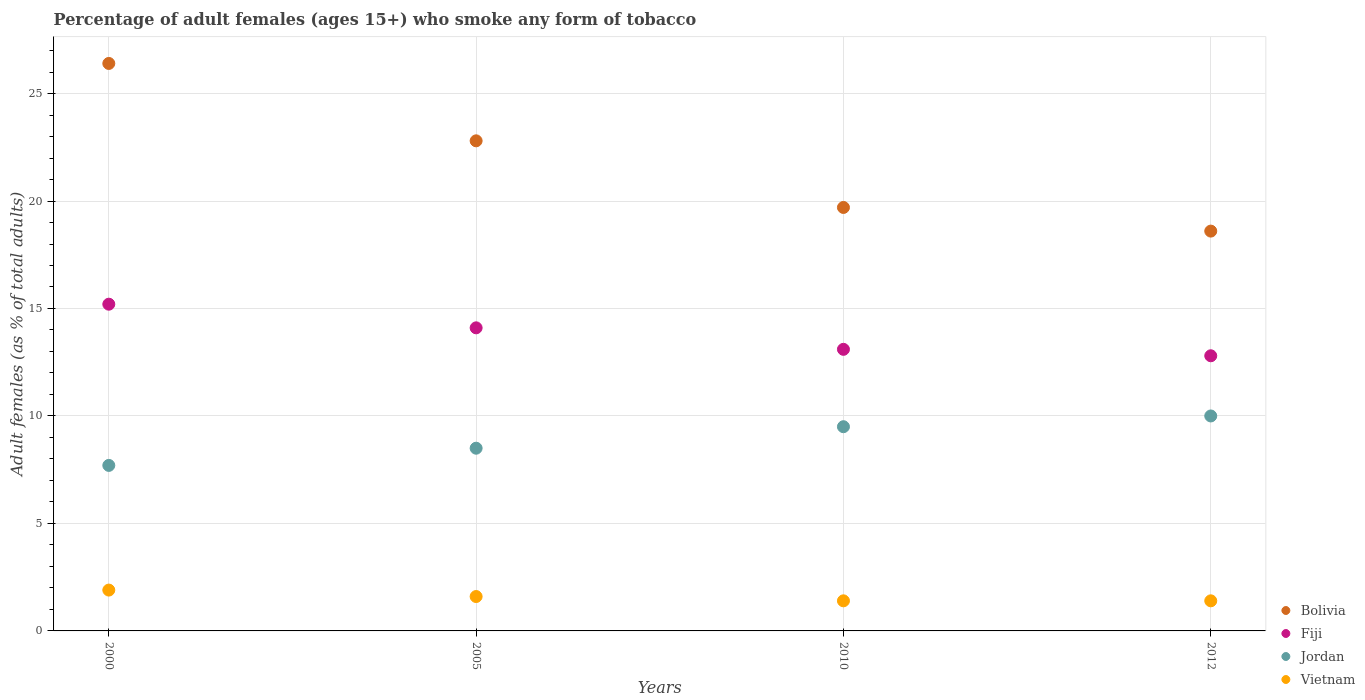How many different coloured dotlines are there?
Keep it short and to the point. 4. What is the percentage of adult females who smoke in Bolivia in 2010?
Your answer should be compact. 19.7. Across all years, what is the maximum percentage of adult females who smoke in Bolivia?
Provide a short and direct response. 26.4. Across all years, what is the minimum percentage of adult females who smoke in Bolivia?
Make the answer very short. 18.6. In which year was the percentage of adult females who smoke in Jordan minimum?
Your answer should be very brief. 2000. What is the total percentage of adult females who smoke in Jordan in the graph?
Your response must be concise. 35.7. What is the difference between the percentage of adult females who smoke in Fiji in 2000 and that in 2012?
Give a very brief answer. 2.4. What is the difference between the percentage of adult females who smoke in Jordan in 2005 and the percentage of adult females who smoke in Fiji in 2010?
Your answer should be very brief. -4.6. What is the average percentage of adult females who smoke in Vietnam per year?
Your answer should be compact. 1.58. In how many years, is the percentage of adult females who smoke in Vietnam greater than 10 %?
Provide a short and direct response. 0. What is the ratio of the percentage of adult females who smoke in Vietnam in 2000 to that in 2005?
Make the answer very short. 1.19. Is the difference between the percentage of adult females who smoke in Bolivia in 2000 and 2010 greater than the difference between the percentage of adult females who smoke in Jordan in 2000 and 2010?
Make the answer very short. Yes. What is the difference between the highest and the second highest percentage of adult females who smoke in Fiji?
Offer a very short reply. 1.1. What is the difference between the highest and the lowest percentage of adult females who smoke in Fiji?
Provide a succinct answer. 2.4. In how many years, is the percentage of adult females who smoke in Fiji greater than the average percentage of adult females who smoke in Fiji taken over all years?
Keep it short and to the point. 2. How many dotlines are there?
Make the answer very short. 4. Are the values on the major ticks of Y-axis written in scientific E-notation?
Offer a very short reply. No. Does the graph contain grids?
Keep it short and to the point. Yes. Where does the legend appear in the graph?
Provide a succinct answer. Bottom right. How are the legend labels stacked?
Provide a succinct answer. Vertical. What is the title of the graph?
Your answer should be very brief. Percentage of adult females (ages 15+) who smoke any form of tobacco. What is the label or title of the Y-axis?
Ensure brevity in your answer.  Adult females (as % of total adults). What is the Adult females (as % of total adults) in Bolivia in 2000?
Provide a succinct answer. 26.4. What is the Adult females (as % of total adults) of Fiji in 2000?
Make the answer very short. 15.2. What is the Adult females (as % of total adults) of Jordan in 2000?
Your response must be concise. 7.7. What is the Adult females (as % of total adults) in Vietnam in 2000?
Offer a very short reply. 1.9. What is the Adult females (as % of total adults) of Bolivia in 2005?
Give a very brief answer. 22.8. What is the Adult females (as % of total adults) of Jordan in 2005?
Make the answer very short. 8.5. What is the Adult females (as % of total adults) of Fiji in 2010?
Give a very brief answer. 13.1. What is the Adult females (as % of total adults) in Bolivia in 2012?
Offer a terse response. 18.6. Across all years, what is the maximum Adult females (as % of total adults) of Bolivia?
Provide a succinct answer. 26.4. Across all years, what is the maximum Adult females (as % of total adults) in Fiji?
Your answer should be very brief. 15.2. Across all years, what is the minimum Adult females (as % of total adults) of Bolivia?
Your answer should be compact. 18.6. Across all years, what is the minimum Adult females (as % of total adults) in Fiji?
Offer a terse response. 12.8. Across all years, what is the minimum Adult females (as % of total adults) of Jordan?
Ensure brevity in your answer.  7.7. Across all years, what is the minimum Adult females (as % of total adults) in Vietnam?
Provide a short and direct response. 1.4. What is the total Adult females (as % of total adults) in Bolivia in the graph?
Offer a very short reply. 87.5. What is the total Adult females (as % of total adults) of Fiji in the graph?
Your response must be concise. 55.2. What is the total Adult females (as % of total adults) in Jordan in the graph?
Offer a terse response. 35.7. What is the total Adult females (as % of total adults) of Vietnam in the graph?
Your answer should be very brief. 6.3. What is the difference between the Adult females (as % of total adults) in Fiji in 2000 and that in 2005?
Ensure brevity in your answer.  1.1. What is the difference between the Adult females (as % of total adults) of Jordan in 2000 and that in 2005?
Keep it short and to the point. -0.8. What is the difference between the Adult females (as % of total adults) in Bolivia in 2000 and that in 2010?
Ensure brevity in your answer.  6.7. What is the difference between the Adult females (as % of total adults) in Fiji in 2000 and that in 2012?
Offer a terse response. 2.4. What is the difference between the Adult females (as % of total adults) in Fiji in 2005 and that in 2010?
Ensure brevity in your answer.  1. What is the difference between the Adult females (as % of total adults) in Jordan in 2005 and that in 2010?
Provide a succinct answer. -1. What is the difference between the Adult females (as % of total adults) in Bolivia in 2005 and that in 2012?
Provide a short and direct response. 4.2. What is the difference between the Adult females (as % of total adults) in Fiji in 2005 and that in 2012?
Offer a very short reply. 1.3. What is the difference between the Adult females (as % of total adults) in Bolivia in 2010 and that in 2012?
Give a very brief answer. 1.1. What is the difference between the Adult females (as % of total adults) in Jordan in 2010 and that in 2012?
Your response must be concise. -0.5. What is the difference between the Adult females (as % of total adults) of Vietnam in 2010 and that in 2012?
Provide a succinct answer. 0. What is the difference between the Adult females (as % of total adults) of Bolivia in 2000 and the Adult females (as % of total adults) of Vietnam in 2005?
Your response must be concise. 24.8. What is the difference between the Adult females (as % of total adults) of Fiji in 2000 and the Adult females (as % of total adults) of Vietnam in 2005?
Give a very brief answer. 13.6. What is the difference between the Adult females (as % of total adults) of Bolivia in 2000 and the Adult females (as % of total adults) of Jordan in 2010?
Your answer should be very brief. 16.9. What is the difference between the Adult females (as % of total adults) of Jordan in 2000 and the Adult females (as % of total adults) of Vietnam in 2010?
Your answer should be compact. 6.3. What is the difference between the Adult females (as % of total adults) in Bolivia in 2000 and the Adult females (as % of total adults) in Fiji in 2012?
Provide a short and direct response. 13.6. What is the difference between the Adult females (as % of total adults) of Bolivia in 2000 and the Adult females (as % of total adults) of Vietnam in 2012?
Your answer should be very brief. 25. What is the difference between the Adult females (as % of total adults) of Fiji in 2000 and the Adult females (as % of total adults) of Vietnam in 2012?
Your answer should be very brief. 13.8. What is the difference between the Adult females (as % of total adults) in Bolivia in 2005 and the Adult females (as % of total adults) in Fiji in 2010?
Offer a very short reply. 9.7. What is the difference between the Adult females (as % of total adults) in Bolivia in 2005 and the Adult females (as % of total adults) in Vietnam in 2010?
Provide a succinct answer. 21.4. What is the difference between the Adult females (as % of total adults) of Fiji in 2005 and the Adult females (as % of total adults) of Jordan in 2010?
Give a very brief answer. 4.6. What is the difference between the Adult females (as % of total adults) in Fiji in 2005 and the Adult females (as % of total adults) in Vietnam in 2010?
Offer a terse response. 12.7. What is the difference between the Adult females (as % of total adults) in Bolivia in 2005 and the Adult females (as % of total adults) in Fiji in 2012?
Make the answer very short. 10. What is the difference between the Adult females (as % of total adults) in Bolivia in 2005 and the Adult females (as % of total adults) in Jordan in 2012?
Keep it short and to the point. 12.8. What is the difference between the Adult females (as % of total adults) of Bolivia in 2005 and the Adult females (as % of total adults) of Vietnam in 2012?
Make the answer very short. 21.4. What is the difference between the Adult females (as % of total adults) in Fiji in 2005 and the Adult females (as % of total adults) in Vietnam in 2012?
Keep it short and to the point. 12.7. What is the difference between the Adult females (as % of total adults) of Jordan in 2005 and the Adult females (as % of total adults) of Vietnam in 2012?
Keep it short and to the point. 7.1. What is the difference between the Adult females (as % of total adults) of Bolivia in 2010 and the Adult females (as % of total adults) of Jordan in 2012?
Keep it short and to the point. 9.7. What is the difference between the Adult females (as % of total adults) in Fiji in 2010 and the Adult females (as % of total adults) in Jordan in 2012?
Offer a terse response. 3.1. What is the difference between the Adult females (as % of total adults) in Fiji in 2010 and the Adult females (as % of total adults) in Vietnam in 2012?
Provide a short and direct response. 11.7. What is the difference between the Adult females (as % of total adults) of Jordan in 2010 and the Adult females (as % of total adults) of Vietnam in 2012?
Offer a terse response. 8.1. What is the average Adult females (as % of total adults) of Bolivia per year?
Keep it short and to the point. 21.88. What is the average Adult females (as % of total adults) of Fiji per year?
Provide a short and direct response. 13.8. What is the average Adult females (as % of total adults) in Jordan per year?
Your response must be concise. 8.93. What is the average Adult females (as % of total adults) in Vietnam per year?
Offer a very short reply. 1.57. In the year 2000, what is the difference between the Adult females (as % of total adults) in Bolivia and Adult females (as % of total adults) in Fiji?
Offer a very short reply. 11.2. In the year 2000, what is the difference between the Adult females (as % of total adults) of Fiji and Adult females (as % of total adults) of Jordan?
Your response must be concise. 7.5. In the year 2000, what is the difference between the Adult females (as % of total adults) in Fiji and Adult females (as % of total adults) in Vietnam?
Keep it short and to the point. 13.3. In the year 2000, what is the difference between the Adult females (as % of total adults) of Jordan and Adult females (as % of total adults) of Vietnam?
Make the answer very short. 5.8. In the year 2005, what is the difference between the Adult females (as % of total adults) of Bolivia and Adult females (as % of total adults) of Vietnam?
Ensure brevity in your answer.  21.2. In the year 2005, what is the difference between the Adult females (as % of total adults) of Fiji and Adult females (as % of total adults) of Jordan?
Give a very brief answer. 5.6. In the year 2010, what is the difference between the Adult females (as % of total adults) of Bolivia and Adult females (as % of total adults) of Fiji?
Give a very brief answer. 6.6. In the year 2010, what is the difference between the Adult females (as % of total adults) of Bolivia and Adult females (as % of total adults) of Vietnam?
Ensure brevity in your answer.  18.3. In the year 2012, what is the difference between the Adult females (as % of total adults) of Bolivia and Adult females (as % of total adults) of Jordan?
Provide a succinct answer. 8.6. In the year 2012, what is the difference between the Adult females (as % of total adults) of Bolivia and Adult females (as % of total adults) of Vietnam?
Keep it short and to the point. 17.2. In the year 2012, what is the difference between the Adult females (as % of total adults) of Fiji and Adult females (as % of total adults) of Jordan?
Offer a terse response. 2.8. In the year 2012, what is the difference between the Adult females (as % of total adults) of Jordan and Adult females (as % of total adults) of Vietnam?
Your answer should be compact. 8.6. What is the ratio of the Adult females (as % of total adults) in Bolivia in 2000 to that in 2005?
Offer a very short reply. 1.16. What is the ratio of the Adult females (as % of total adults) in Fiji in 2000 to that in 2005?
Your answer should be very brief. 1.08. What is the ratio of the Adult females (as % of total adults) of Jordan in 2000 to that in 2005?
Offer a terse response. 0.91. What is the ratio of the Adult females (as % of total adults) in Vietnam in 2000 to that in 2005?
Your response must be concise. 1.19. What is the ratio of the Adult females (as % of total adults) in Bolivia in 2000 to that in 2010?
Your response must be concise. 1.34. What is the ratio of the Adult females (as % of total adults) of Fiji in 2000 to that in 2010?
Ensure brevity in your answer.  1.16. What is the ratio of the Adult females (as % of total adults) in Jordan in 2000 to that in 2010?
Your response must be concise. 0.81. What is the ratio of the Adult females (as % of total adults) in Vietnam in 2000 to that in 2010?
Ensure brevity in your answer.  1.36. What is the ratio of the Adult females (as % of total adults) in Bolivia in 2000 to that in 2012?
Give a very brief answer. 1.42. What is the ratio of the Adult females (as % of total adults) of Fiji in 2000 to that in 2012?
Your response must be concise. 1.19. What is the ratio of the Adult females (as % of total adults) in Jordan in 2000 to that in 2012?
Give a very brief answer. 0.77. What is the ratio of the Adult females (as % of total adults) in Vietnam in 2000 to that in 2012?
Ensure brevity in your answer.  1.36. What is the ratio of the Adult females (as % of total adults) of Bolivia in 2005 to that in 2010?
Offer a very short reply. 1.16. What is the ratio of the Adult females (as % of total adults) in Fiji in 2005 to that in 2010?
Your answer should be compact. 1.08. What is the ratio of the Adult females (as % of total adults) in Jordan in 2005 to that in 2010?
Provide a succinct answer. 0.89. What is the ratio of the Adult females (as % of total adults) of Vietnam in 2005 to that in 2010?
Make the answer very short. 1.14. What is the ratio of the Adult females (as % of total adults) in Bolivia in 2005 to that in 2012?
Your answer should be compact. 1.23. What is the ratio of the Adult females (as % of total adults) in Fiji in 2005 to that in 2012?
Offer a terse response. 1.1. What is the ratio of the Adult females (as % of total adults) of Vietnam in 2005 to that in 2012?
Provide a succinct answer. 1.14. What is the ratio of the Adult females (as % of total adults) in Bolivia in 2010 to that in 2012?
Your response must be concise. 1.06. What is the ratio of the Adult females (as % of total adults) in Fiji in 2010 to that in 2012?
Offer a very short reply. 1.02. What is the ratio of the Adult females (as % of total adults) in Jordan in 2010 to that in 2012?
Provide a succinct answer. 0.95. What is the difference between the highest and the second highest Adult females (as % of total adults) in Vietnam?
Your response must be concise. 0.3. What is the difference between the highest and the lowest Adult females (as % of total adults) of Fiji?
Your response must be concise. 2.4. What is the difference between the highest and the lowest Adult females (as % of total adults) in Vietnam?
Offer a terse response. 0.5. 